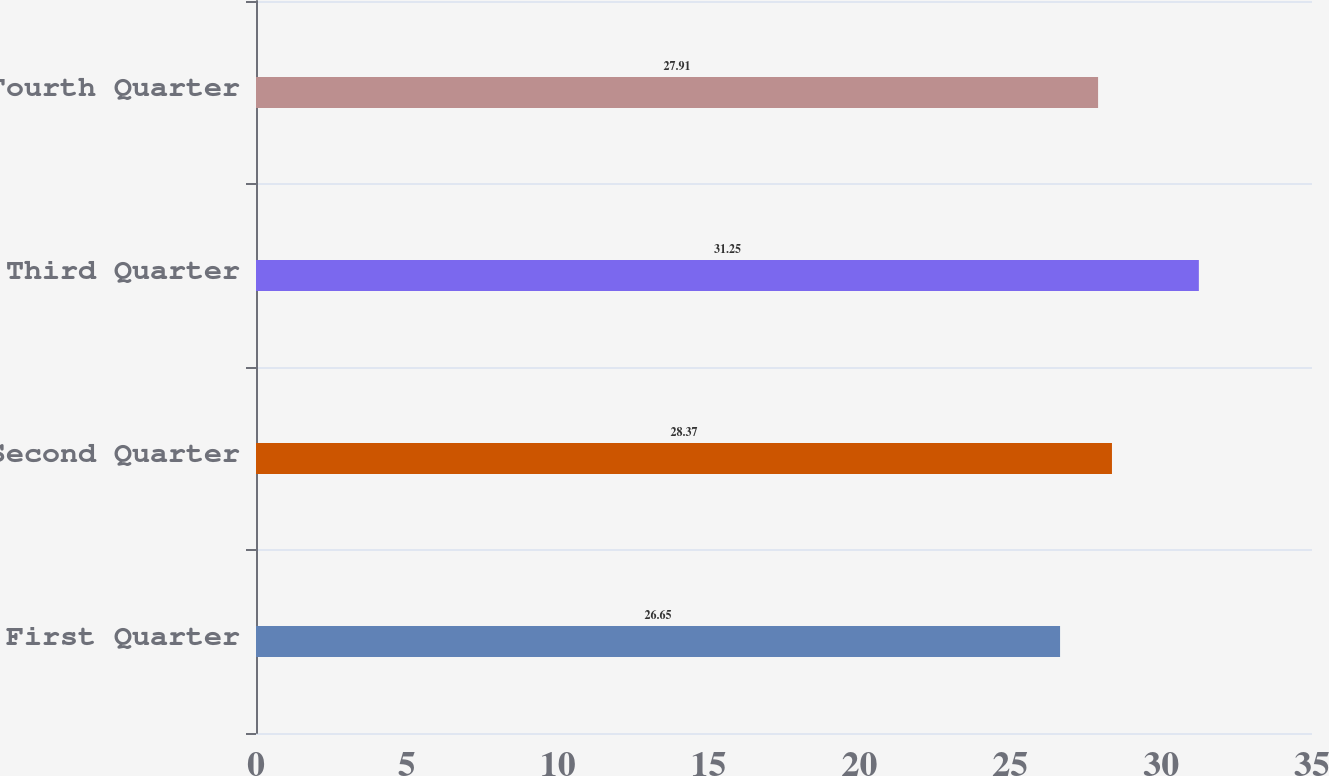<chart> <loc_0><loc_0><loc_500><loc_500><bar_chart><fcel>First Quarter<fcel>Second Quarter<fcel>Third Quarter<fcel>Fourth Quarter<nl><fcel>26.65<fcel>28.37<fcel>31.25<fcel>27.91<nl></chart> 